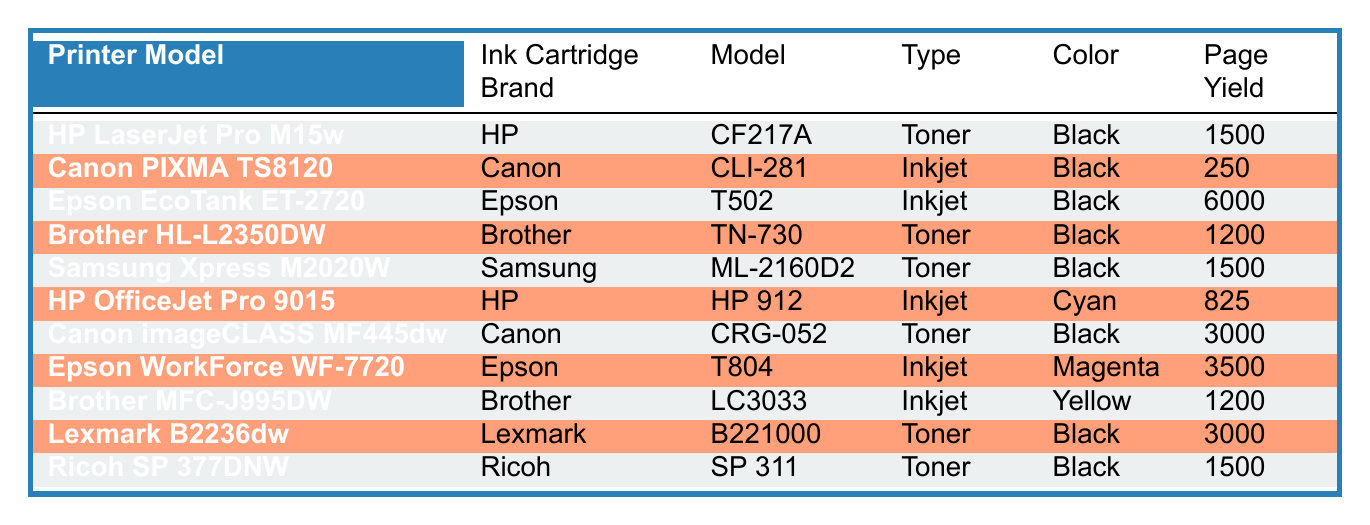What ink cartridge model is used by the HP LaserJet Pro M15w? The table shows that the ink cartridge model used by the HP LaserJet Pro M15w is CF217A.
Answer: CF217A How many pages can the Epson EcoTank ET-2720 print with one cartridge? According to the table, the page yield for the Epson EcoTank ET-2720 is 6000 pages.
Answer: 6000 Which printer model uses the Brother TN-730 toner cartridge? From the table, the Brother HL-L2350DW printer model is listed with the Brother TN-730 toner cartridge.
Answer: Brother HL-L2350DW Is the Canon CLI-281 cartridge compatible with any inkjet printer? Yes, the Canon CLI-281 is specified for use with the Canon PIXMA TS8120 inkjet printer in the table.
Answer: Yes What is the total page yield for all the toner cartridges listed? To find the total, sum the page yields of all toner cartridges: 1500 (HP) + 1200 (Brother) + 1500 (Samsung) + 3000 (Canon) + 3000 (Lexmark) + 1500 (Ricoh) = 12000.
Answer: 12000 What is the color of the ink cartridge used in the HP OfficeJet Pro 9015? The table indicates that the ink cartridge used in the HP OfficeJet Pro 9015 is Cyan.
Answer: Cyan Which printer has the highest page yield among the listed inkjet cartridges? The highest page yield among the inkjet cartridges is 6000 pages, used by the Epson EcoTank ET-2720.
Answer: Epson EcoTank ET-2720 Does the Samsung Xpress M2020W use an inkjet or toner cartridge? The table states that the Samsung Xpress M2020W uses a toner cartridge, specifically model ML-2160D2.
Answer: Toner What printer model is compatible with the Lexmark B221000 cartridge? According to the table, the Lexmark B221000 toner cartridge is used in the Lexmark B2236dw printer model.
Answer: Lexmark B2236dw 